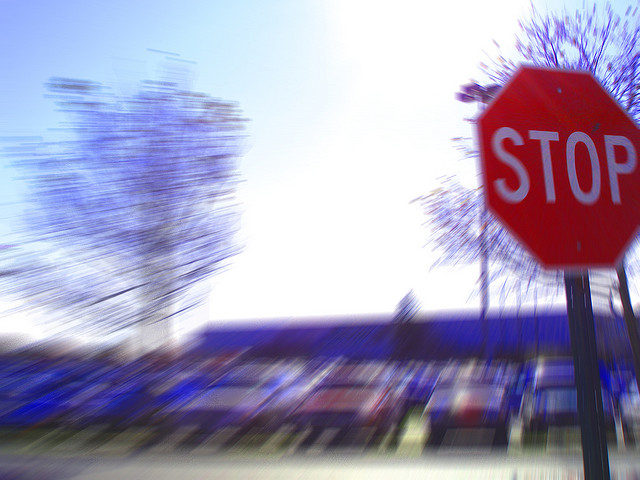Read all the text in this image. STOP 